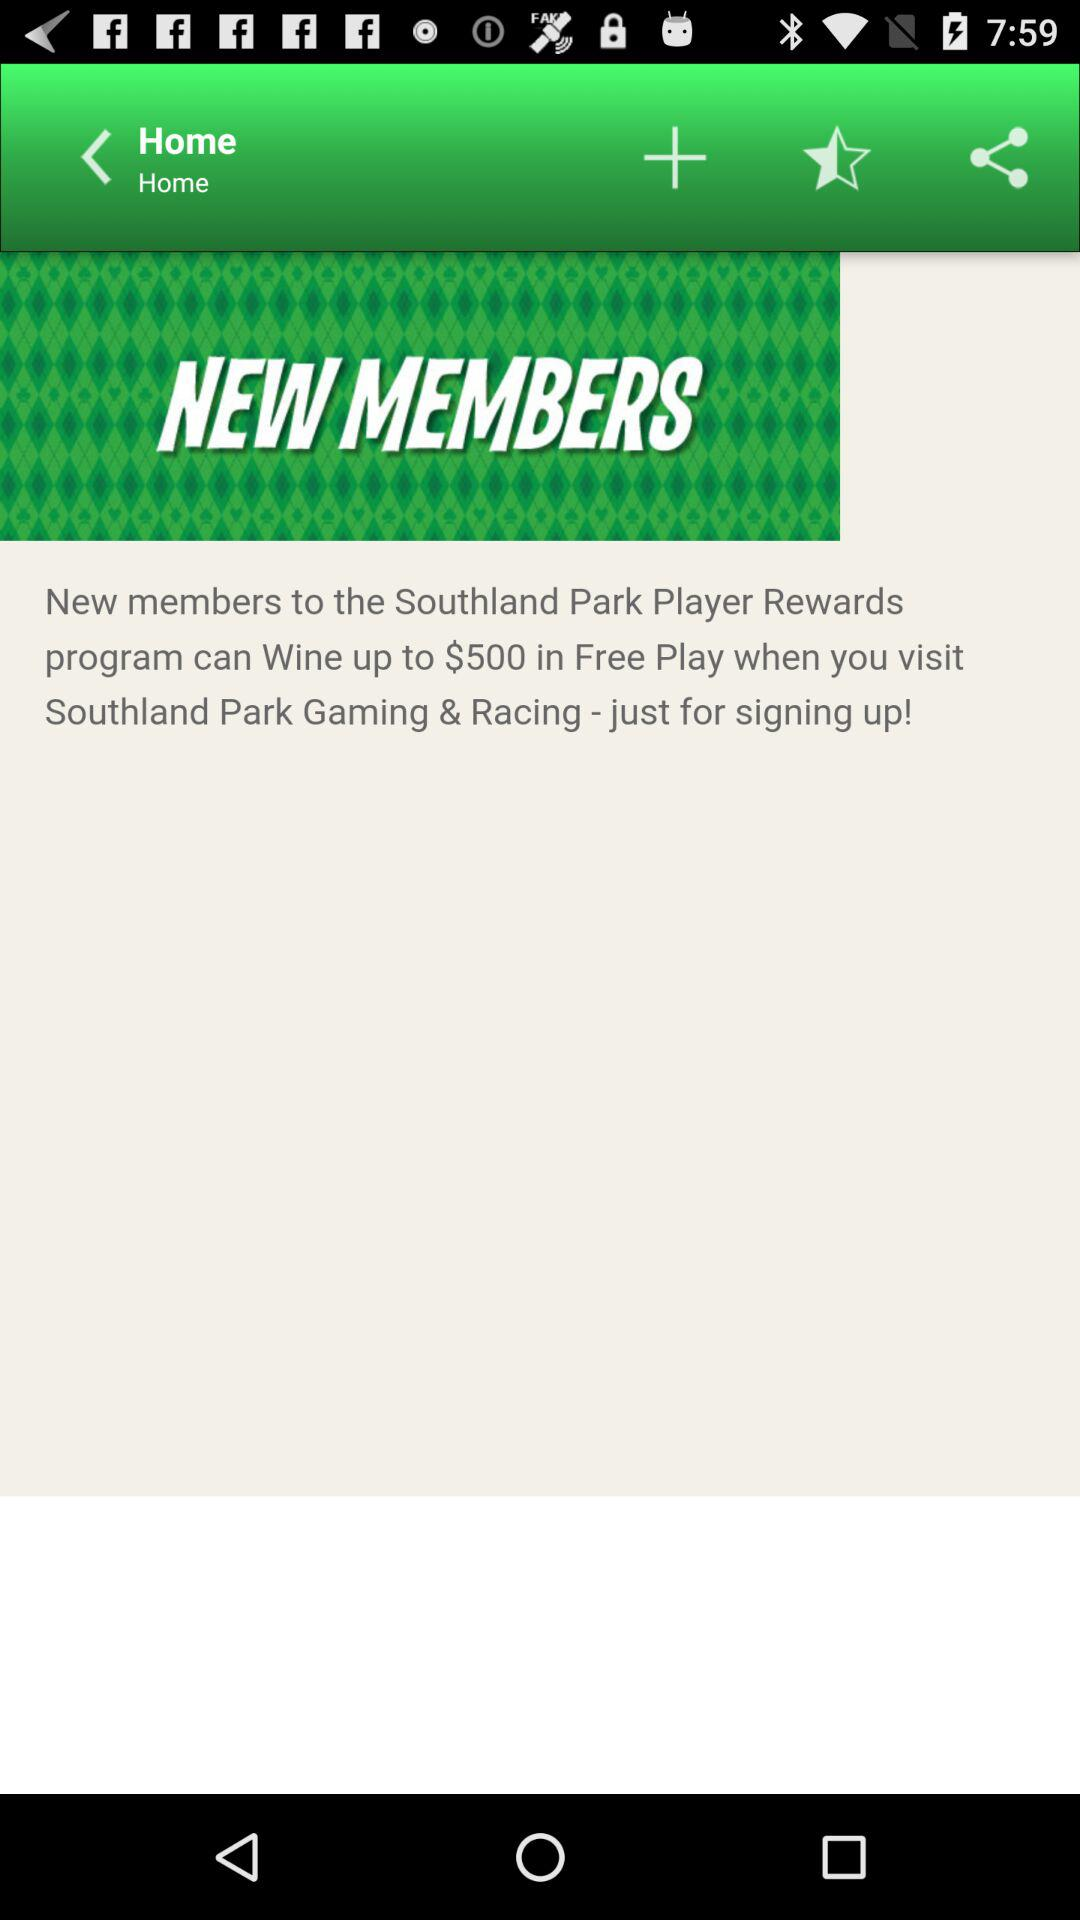How much more free play do new members get if they sign up for the Player Rewards program than if they don't?
Answer the question using a single word or phrase. $500 